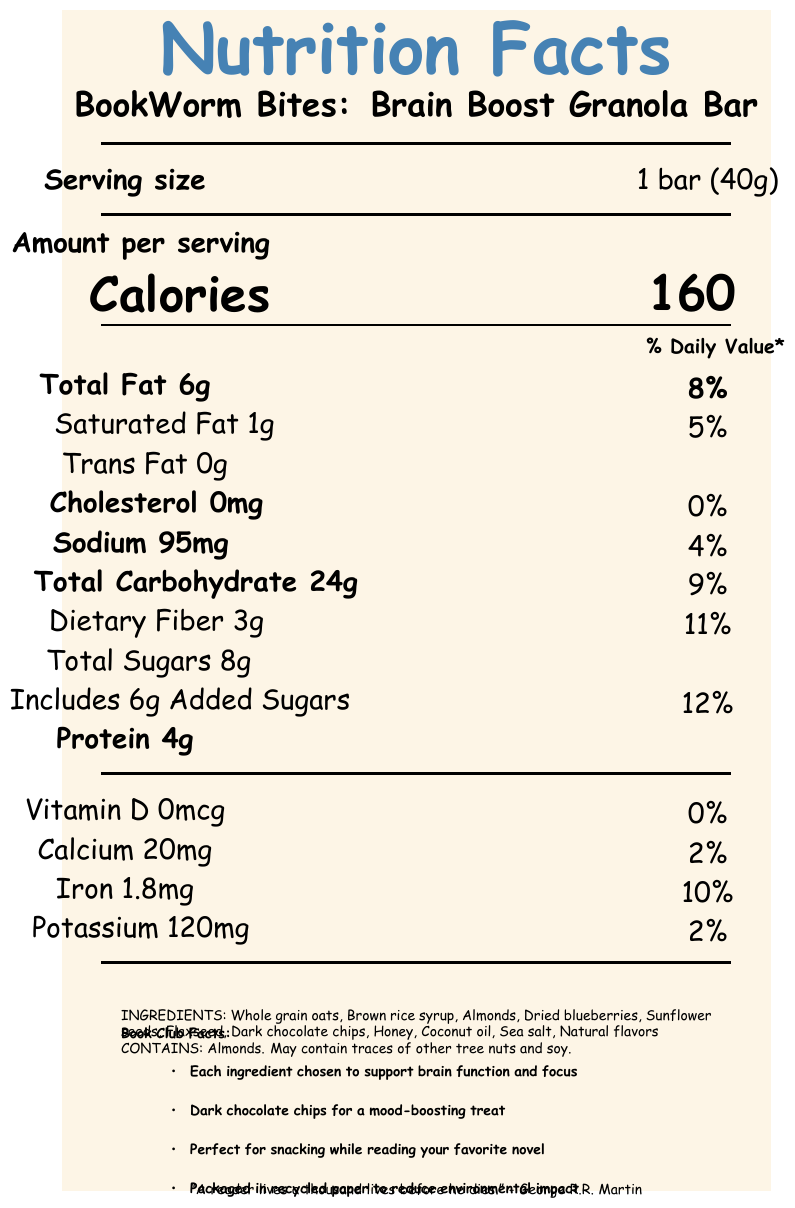how many servings are in the container? The document states that there are 6 servings per container.
Answer: 6 what is the serving size of the granola bar? The document mentions that the serving size is 1 bar (40g).
Answer: 1 bar (40g) how many calories are in one serving of the granola bar? The document specifies that each serving has 160 calories.
Answer: 160 what percentage of the daily value is provided by Total Fat? According to the document, Total Fat contributes 8% of the daily value.
Answer: 8% does the granola bar contain any trans fat? The document lists Trans Fat as 0g.
Answer: No what ingredients are in the granola bar? The document provides a list of the ingredients in the granola bar.
Answer: Whole grain oats, Brown rice syrup, Almonds, Dried blueberries, Sunflower seeds, Flaxseed, Dark chocolate chips, Honey, Coconut oil, Sea salt, Natural flavors what is the daily value percentage for Dietary Fiber in one serving? The document states that one serving of the granola bar provides 11% of the daily value for Dietary Fiber.
Answer: 11% does the granola bar contain any almonds? The document mentions "Contains: Almonds" in the allergen information.
Answer: Yes what is the Daily Value percentage of Iron in one serving? The document shows that Iron has a daily value of 10%.
Answer: 10% how much calcium is in one serving? The document indicates that one serving contains 20mg of calcium.
Answer: 20mg what is the main idea of the nutrition facts document? The document offers comprehensive nutritional data about the granola bar marketed towards teens, focusing on its health benefits and suitability as a snack for reading enthusiasts.
Answer: The document provides detailed nutritional information about the "BookWorm Bites: Brain Boost Granola Bar", including serving size, calories, various nutrients, ingredients, allergen information, and special book club facts. which of these is the primary ingredient of the granola bar? A. Sunflower seeds B. Whole grain oats C. Honey D. Dark chocolate chips The first ingredient listed is Whole grain oats, indicating it is the primary ingredient.
Answer: B what is the main purpose of the Book Club Facts section? A. Provide a list of all ingredients B. Explain the chosen ingredients' health benefits C. Share the calorie count per serving D. Detail the Daily Value percentages The Book Club Facts explain why each ingredient was chosen, such as for brain function, mood-boosting, and environmental impact.
Answer: B does the granola bar contain more than 2g of protein per serving? The document states that each serving contains 4g of protein.
Answer: Yes can you determine the price of the granola bar from this document? The document provides nutritional data but does not include any pricing information.
Answer: Not enough information 